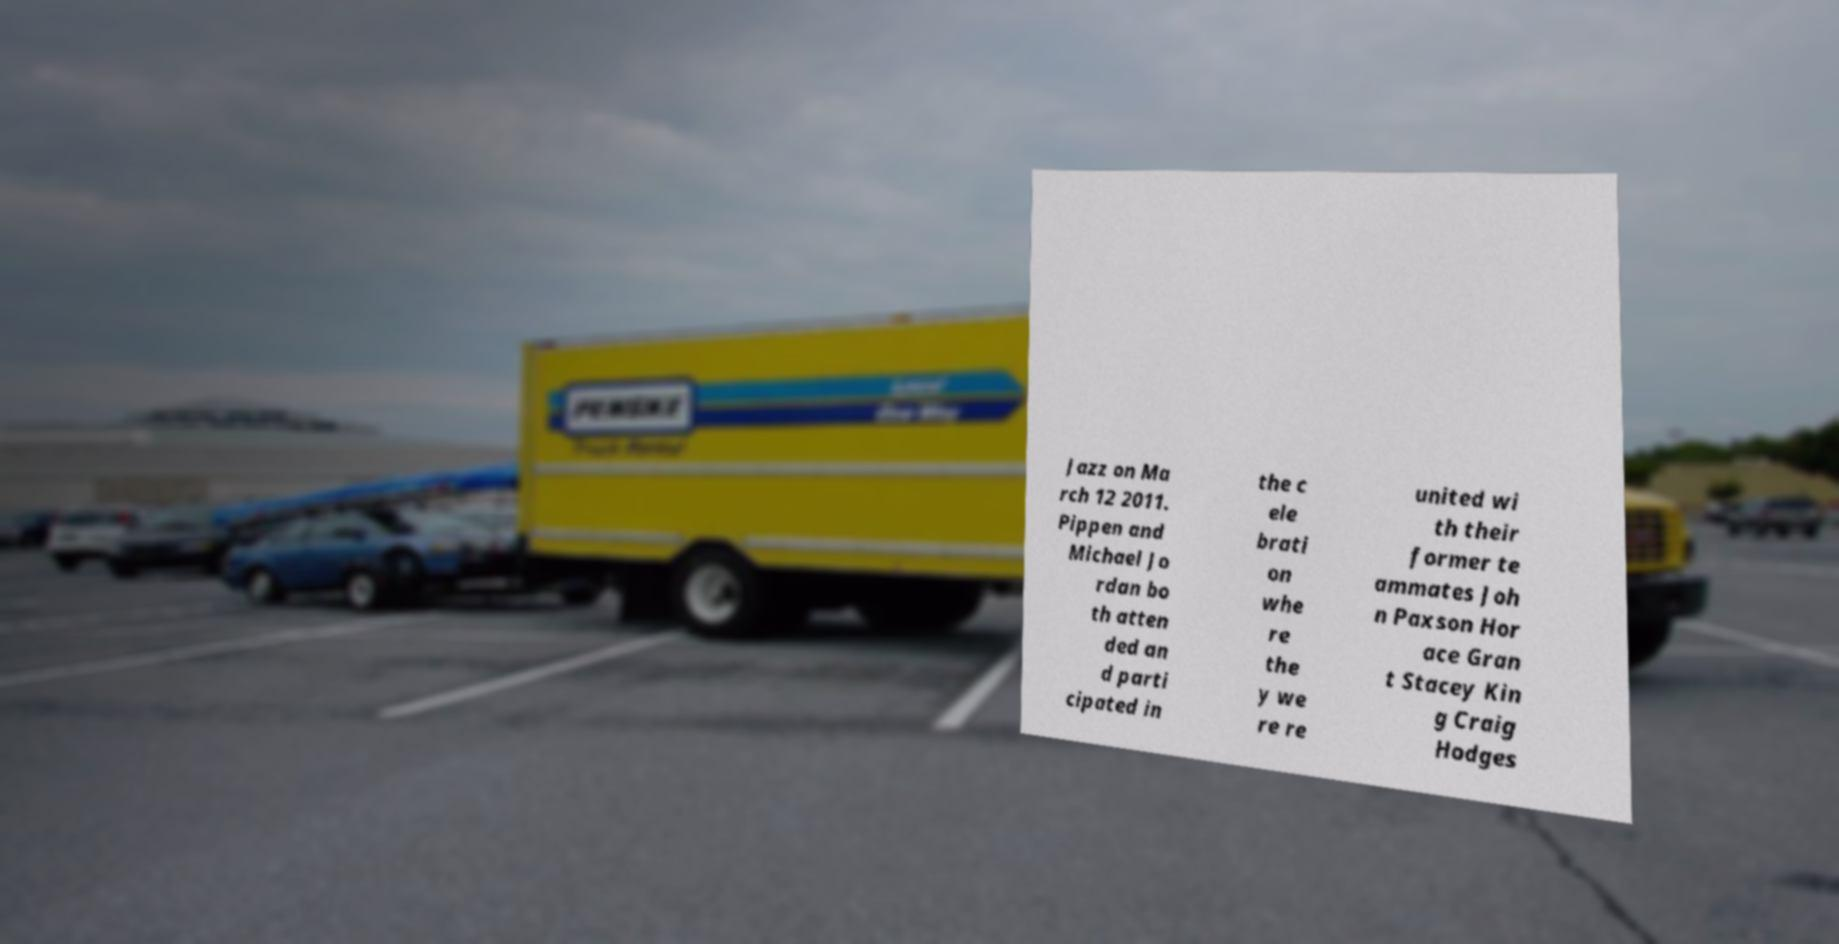Could you assist in decoding the text presented in this image and type it out clearly? Jazz on Ma rch 12 2011. Pippen and Michael Jo rdan bo th atten ded an d parti cipated in the c ele brati on whe re the y we re re united wi th their former te ammates Joh n Paxson Hor ace Gran t Stacey Kin g Craig Hodges 